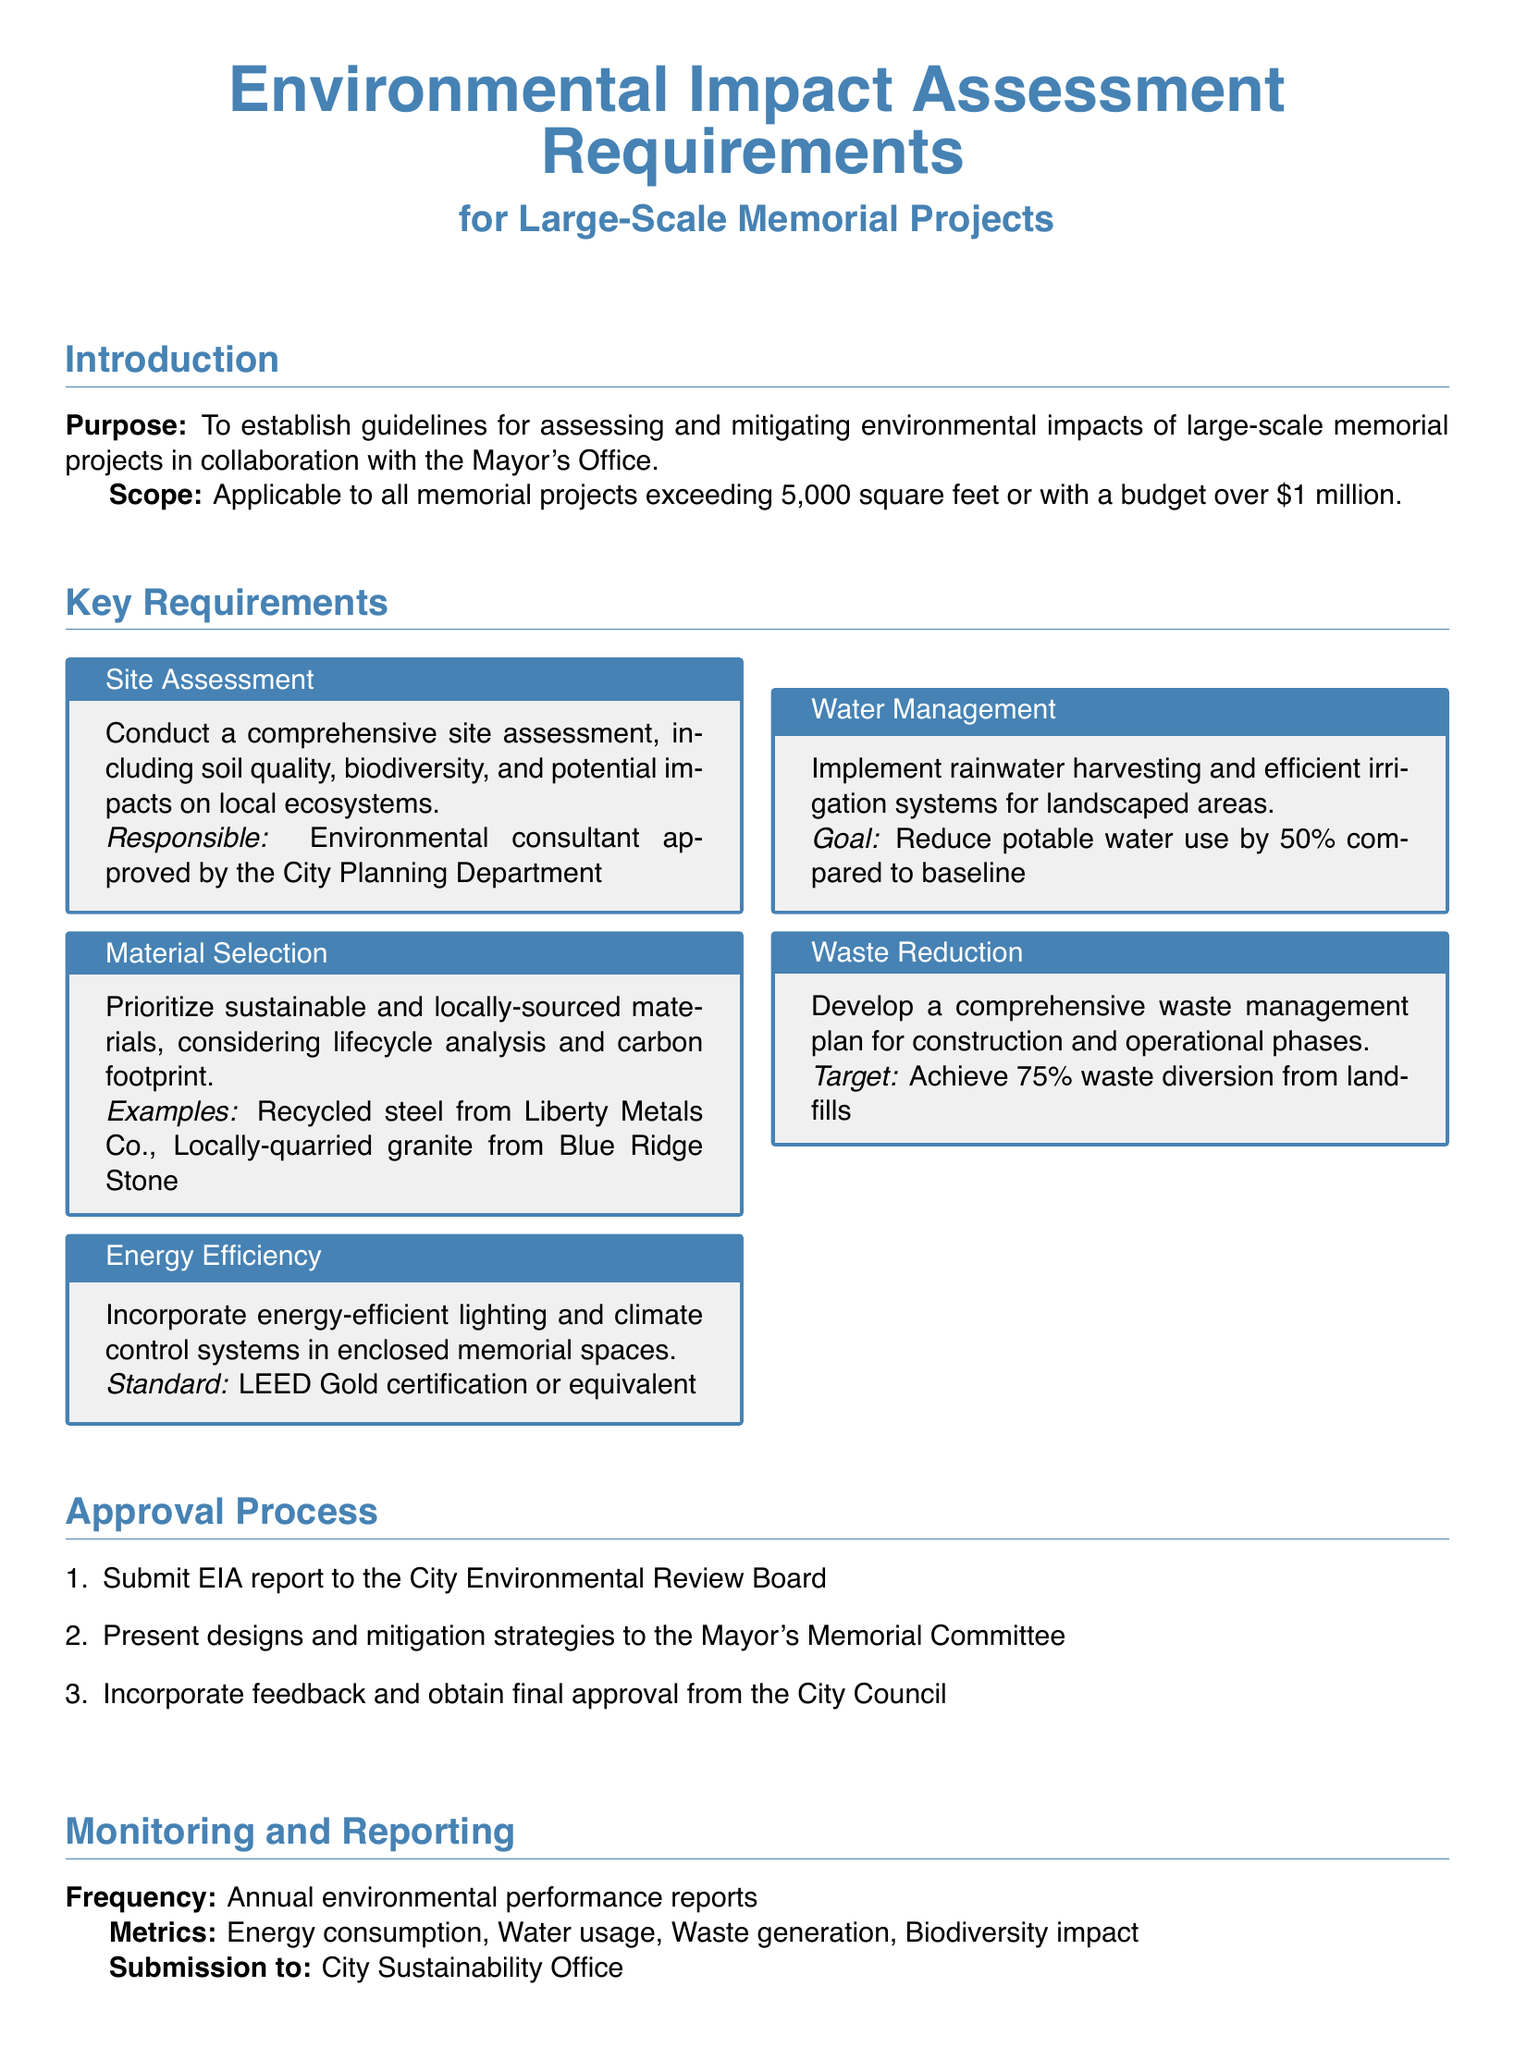What is the purpose of the document? The purpose is to establish guidelines for assessing and mitigating environmental impacts of large-scale memorial projects.
Answer: To establish guidelines for assessing and mitigating environmental impacts What is the minimum project size to require an Environmental Impact Assessment? The threshold for requiring an assessment is projects exceeding 5,000 square feet or with a budget over $1 million.
Answer: 5,000 square feet or $1 million Who is responsible for conducting the site assessment? The site assessment is to be conducted by an environmental consultant approved by the City Planning Department.
Answer: Environmental consultant approved by the City Planning Department What energy standard must memorial projects aim for? Memorial projects should incorporate energy-efficient systems with a goal of achieving LEED Gold certification or equivalent.
Answer: LEED Gold certification or equivalent What is the waste diversion target for memorial projects? The target is to achieve 75% waste diversion from landfills during the construction and operational phases.
Answer: 75% What types of materials should be prioritized in the project? Sustainable and locally-sourced materials should be prioritized, considering lifecycle analysis and carbon footprint.
Answer: Sustainable and locally-sourced materials How often must annual environmental performance reports be submitted? Reports must be submitted annually to the City Sustainability Office.
Answer: Annually What is the goal for reducing potable water use in landscaped areas? The goal is to reduce potable water use by 50% compared to baseline.
Answer: 50% What must be submitted to the City Environmental Review Board? An EIA report must be submitted to the City Environmental Review Board.
Answer: EIA report 